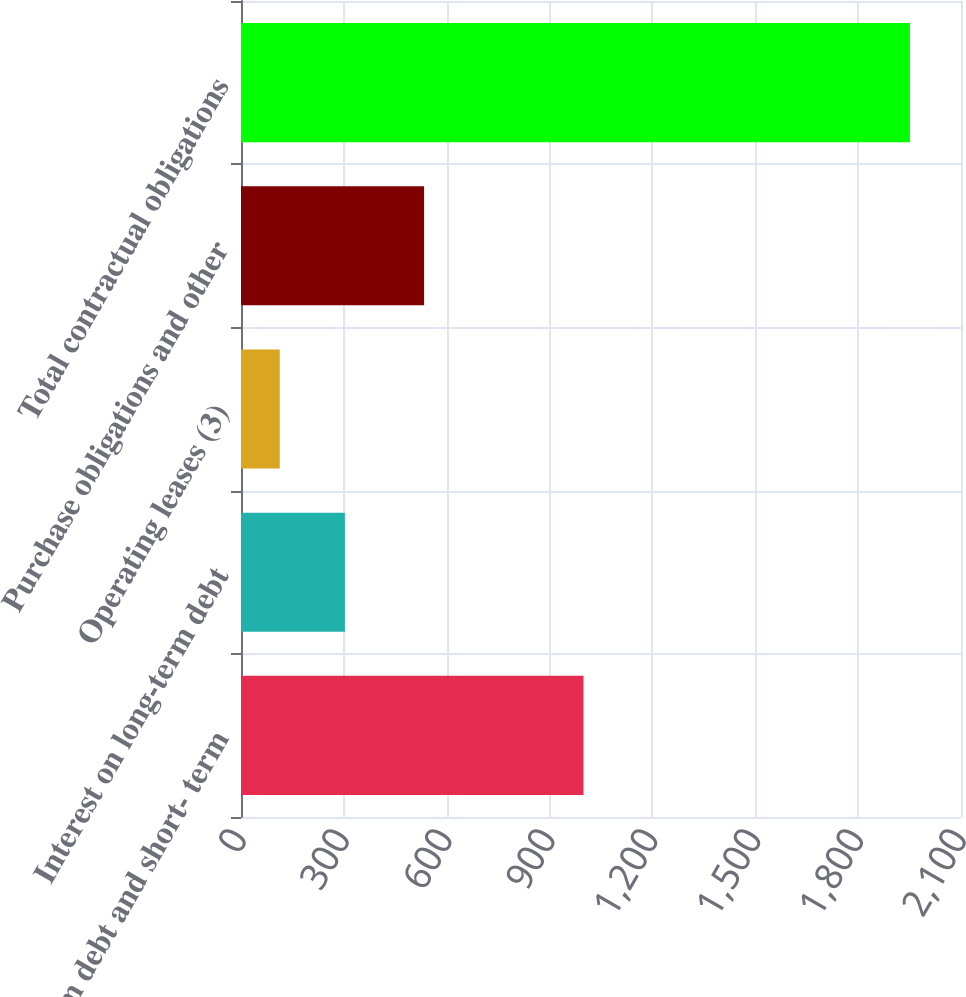Convert chart to OTSL. <chart><loc_0><loc_0><loc_500><loc_500><bar_chart><fcel>Long-term debt and short- term<fcel>Interest on long-term debt<fcel>Operating leases (3)<fcel>Purchase obligations and other<fcel>Total contractual obligations<nl><fcel>999<fcel>303<fcel>113<fcel>534<fcel>1951<nl></chart> 